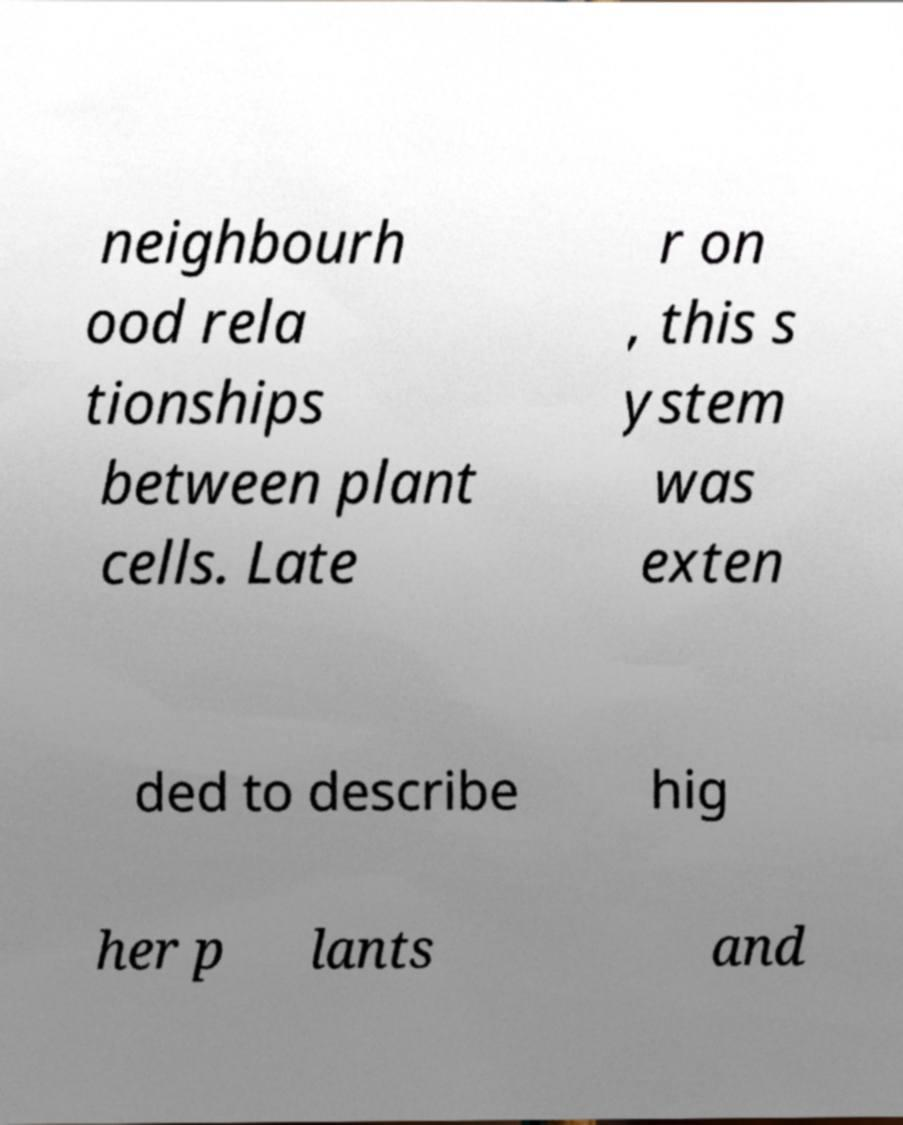Can you read and provide the text displayed in the image?This photo seems to have some interesting text. Can you extract and type it out for me? neighbourh ood rela tionships between plant cells. Late r on , this s ystem was exten ded to describe hig her p lants and 